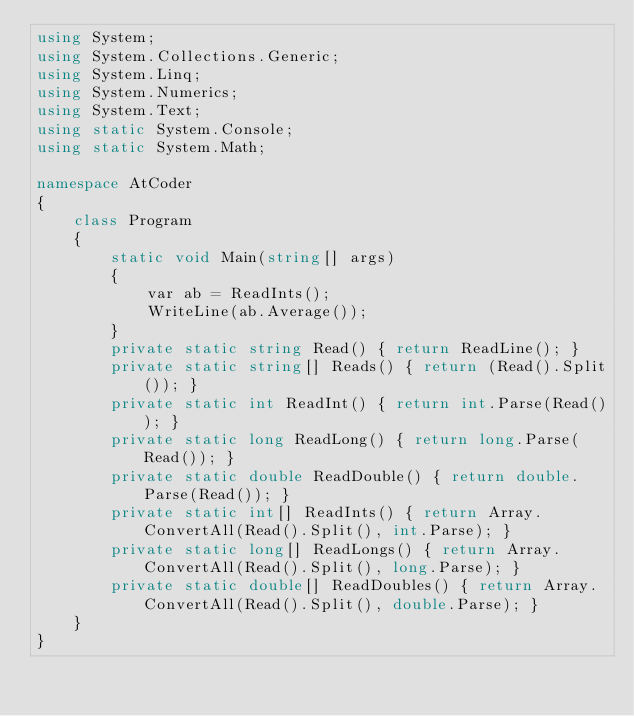<code> <loc_0><loc_0><loc_500><loc_500><_C#_>using System;
using System.Collections.Generic;
using System.Linq;
using System.Numerics;
using System.Text;
using static System.Console;
using static System.Math;

namespace AtCoder
{
    class Program
    {
        static void Main(string[] args)
        {
            var ab = ReadInts();
            WriteLine(ab.Average());
        }
        private static string Read() { return ReadLine(); }
        private static string[] Reads() { return (Read().Split()); }
        private static int ReadInt() { return int.Parse(Read()); }
        private static long ReadLong() { return long.Parse(Read()); }
        private static double ReadDouble() { return double.Parse(Read()); }
        private static int[] ReadInts() { return Array.ConvertAll(Read().Split(), int.Parse); }
        private static long[] ReadLongs() { return Array.ConvertAll(Read().Split(), long.Parse); }
        private static double[] ReadDoubles() { return Array.ConvertAll(Read().Split(), double.Parse); }
    }
}

</code> 